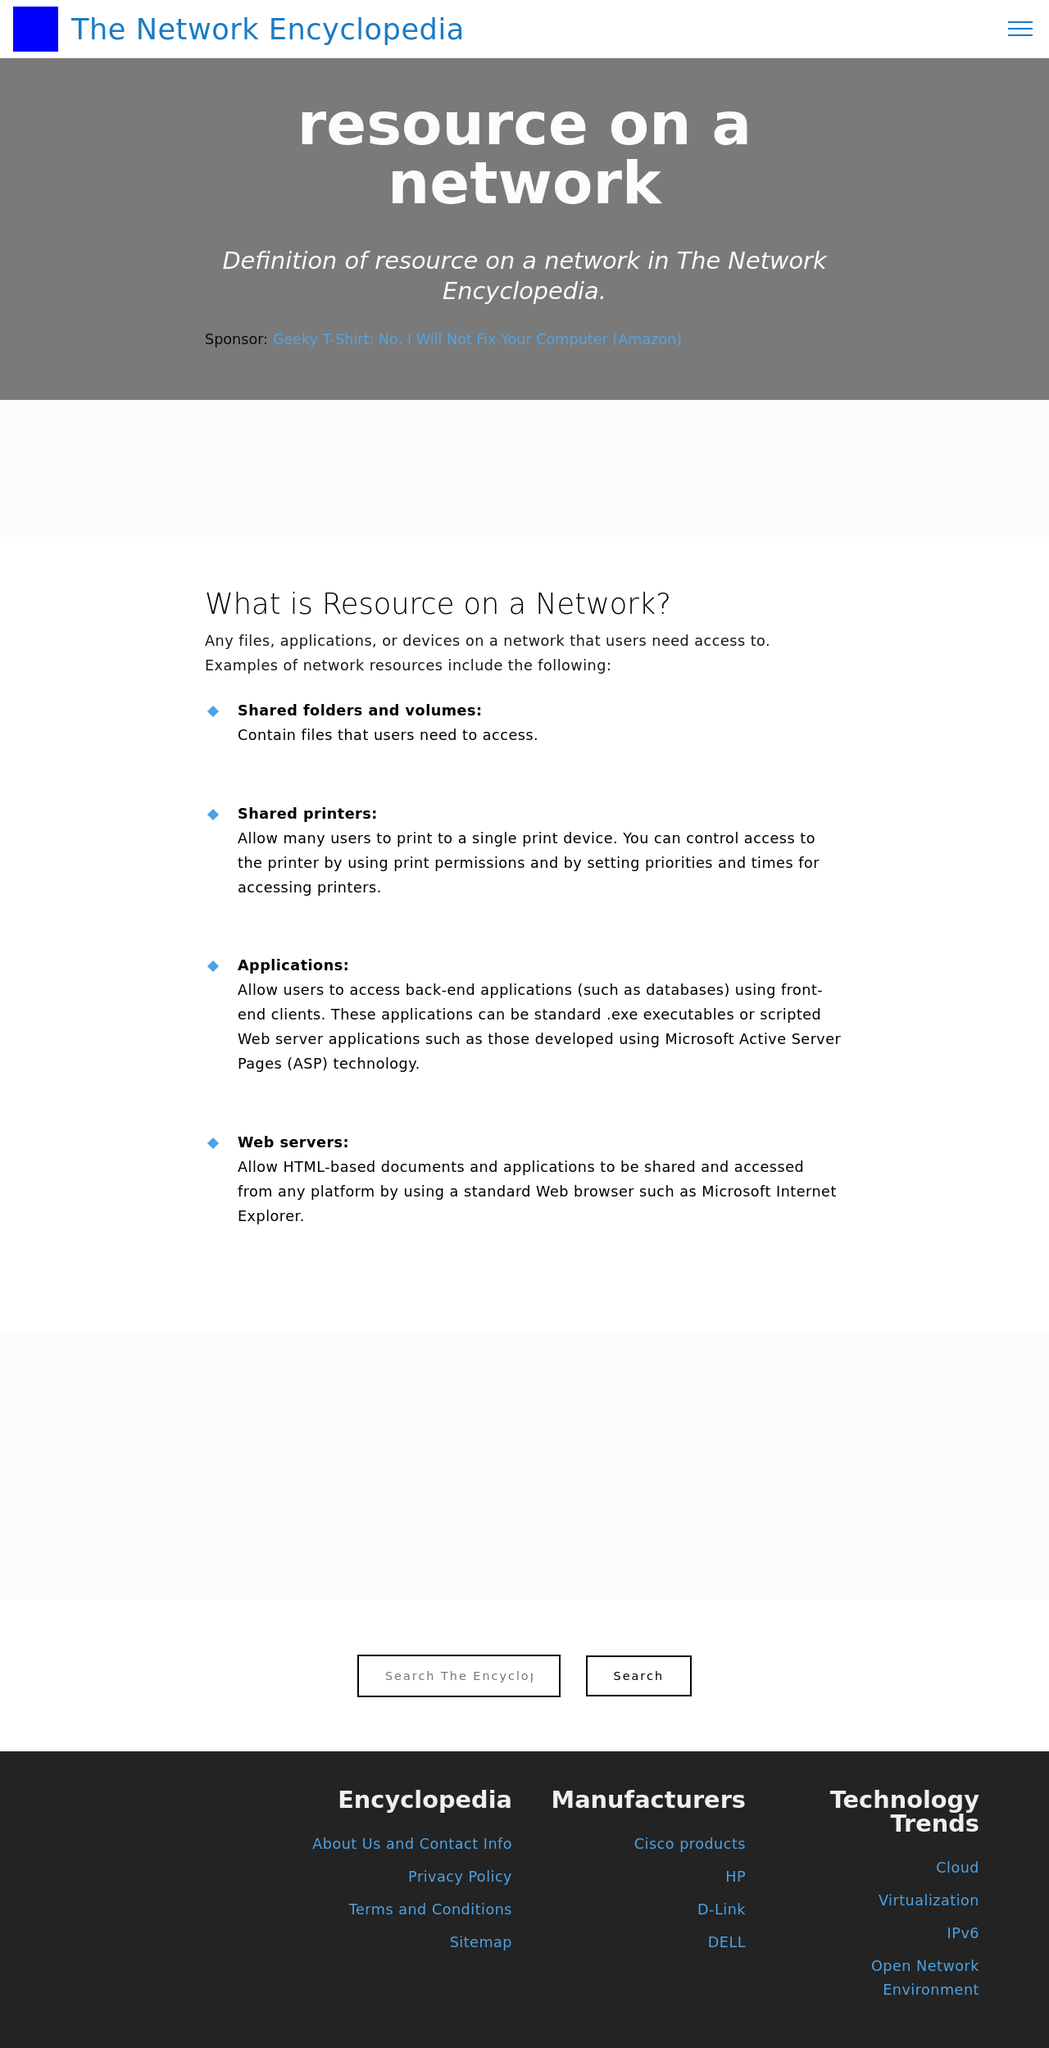Can you explain the purpose of different sections shown in this website layout? The website layout in the image is structured into distinct sections, each serving a specific purpose. The 'Resource on a Network' section seems to describe essential network resources like shared folders and applications, providing definitions and details for educational purposes. The 'Manufacturers' section lists various tech companies, likely offering insights or links to their products and services. Lastly, the 'Technology Trends' section could be discussing current trends in the tech industry such as Cloud, Virtualization, IPv6, helping readers stay informed about the latest in technology.  What do you think could be the target audience for this website? The target audience for this website is likely professionals, students, and enthusiasts in the field of networking and information technology. The content's educational nature on network resources and the focus on manufacturers and tech trends suggest that it aims to inform and educate individuals interested in the latest developments as well as foundational knowledge about networking and IT infrastructure. 